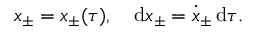Convert formula to latex. <formula><loc_0><loc_0><loc_500><loc_500>x _ { \pm } = x _ { \pm } ( \tau ) , \quad d x _ { \pm } = \dot { x } _ { \pm } \, d \tau .</formula> 